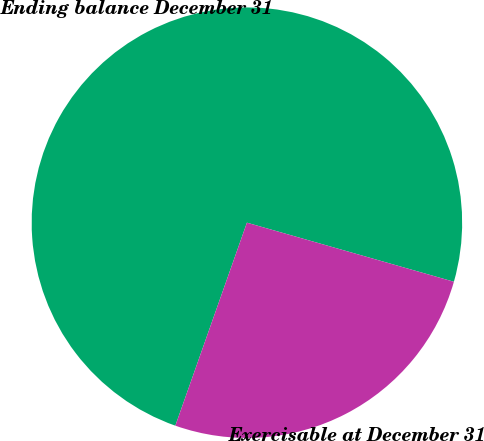Convert chart to OTSL. <chart><loc_0><loc_0><loc_500><loc_500><pie_chart><fcel>Ending balance December 31<fcel>Exercisable at December 31<nl><fcel>74.03%<fcel>25.97%<nl></chart> 